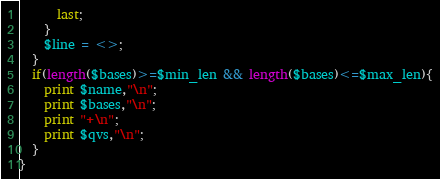<code> <loc_0><loc_0><loc_500><loc_500><_Perl_>      last;
    }
    $line = <>;
  }
  if(length($bases)>=$min_len && length($bases)<=$max_len){
    print $name,"\n";
    print $bases,"\n";
    print "+\n";
    print $qvs,"\n";
  }
}
</code> 